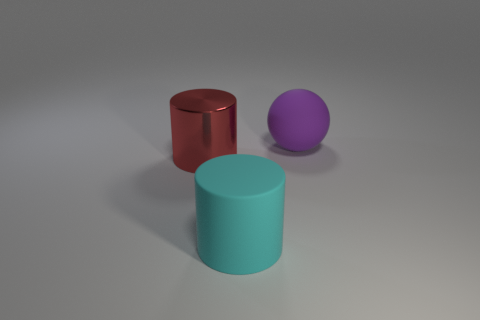Add 3 big purple metallic cubes. How many objects exist? 6 Subtract all cylinders. How many objects are left? 1 Subtract all large cyan objects. Subtract all big cyan objects. How many objects are left? 1 Add 1 rubber cylinders. How many rubber cylinders are left? 2 Add 2 cylinders. How many cylinders exist? 4 Subtract 1 red cylinders. How many objects are left? 2 